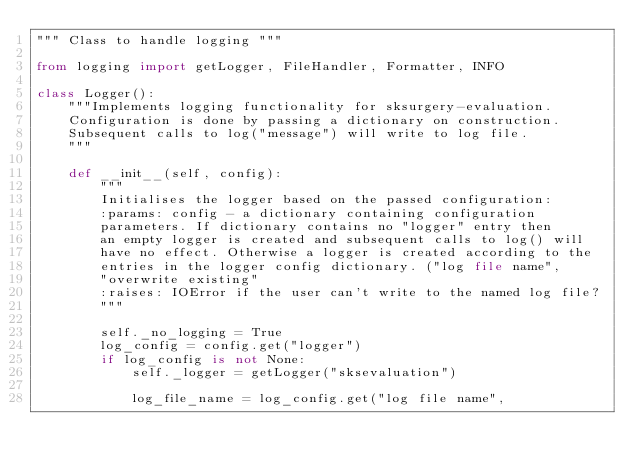Convert code to text. <code><loc_0><loc_0><loc_500><loc_500><_Python_>""" Class to handle logging """

from logging import getLogger, FileHandler, Formatter, INFO

class Logger():
    """Implements logging functionality for sksurgery-evaluation.
    Configuration is done by passing a dictionary on construction.
    Subsequent calls to log("message") will write to log file.
    """

    def __init__(self, config):
        """
        Initialises the logger based on the passed configuration:
        :params: config - a dictionary containing configuration
        parameters. If dictionary contains no "logger" entry then
        an empty logger is created and subsequent calls to log() will
        have no effect. Otherwise a logger is created according to the
        entries in the logger config dictionary. ("log file name",
        "overwrite existing"
        :raises: IOError if the user can't write to the named log file?
        """

        self._no_logging = True
        log_config = config.get("logger")
        if log_config is not None:
            self._logger = getLogger("sksevaluation")

            log_file_name = log_config.get("log file name",</code> 